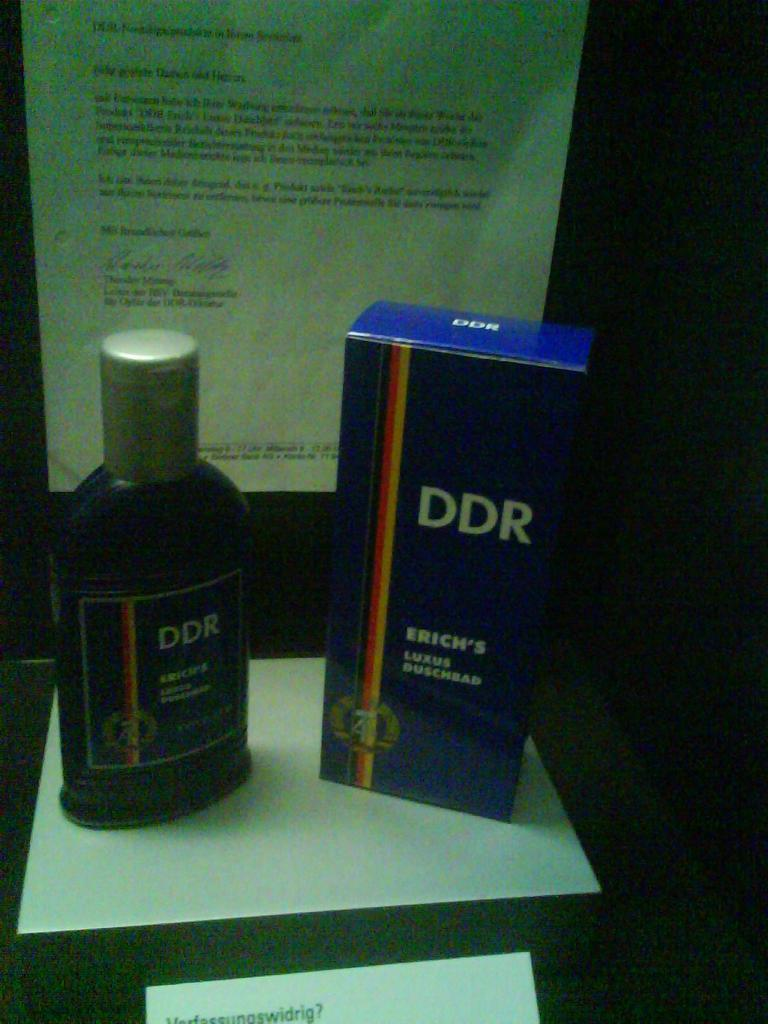Provide a one-sentence caption for the provided image. A bottle and a box of DDR are shown in front of a letter. 